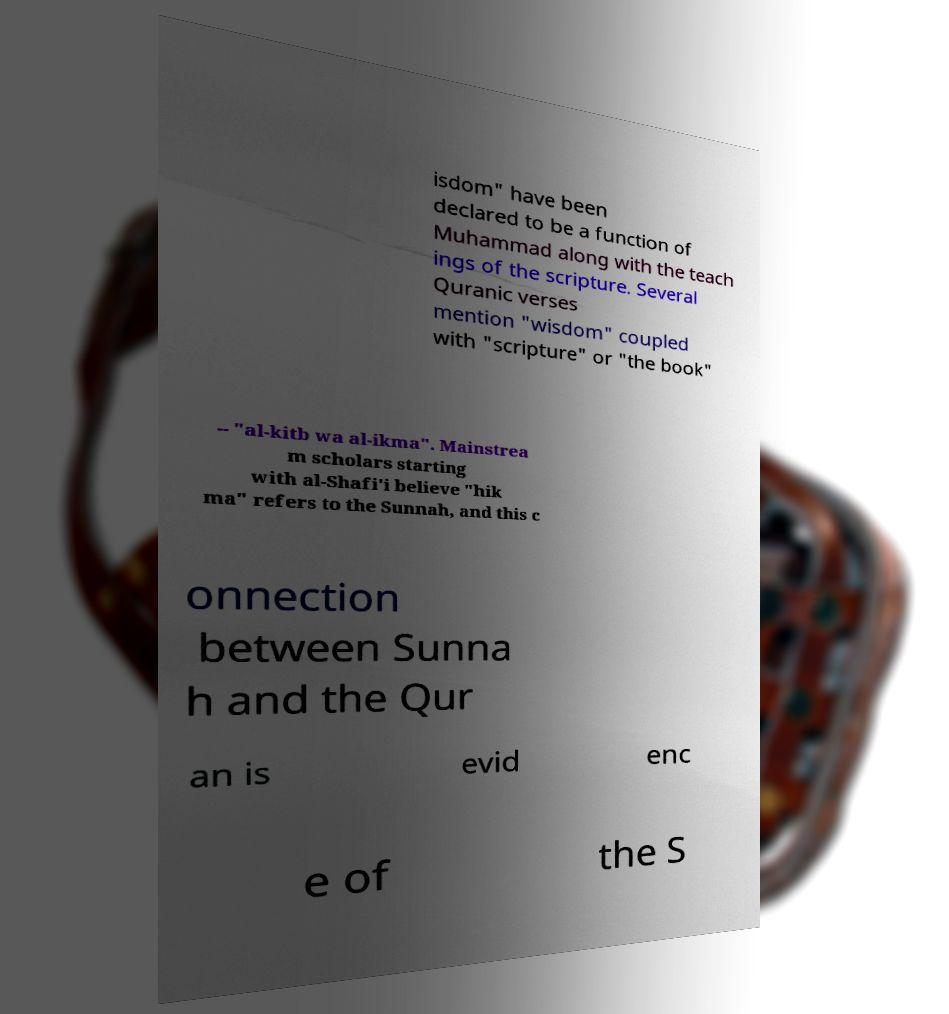Could you extract and type out the text from this image? isdom" have been declared to be a function of Muhammad along with the teach ings of the scripture. Several Quranic verses mention "wisdom" coupled with "scripture" or "the book" -- "al-kitb wa al-ikma". Mainstrea m scholars starting with al-Shafi'i believe "hik ma" refers to the Sunnah, and this c onnection between Sunna h and the Qur an is evid enc e of the S 